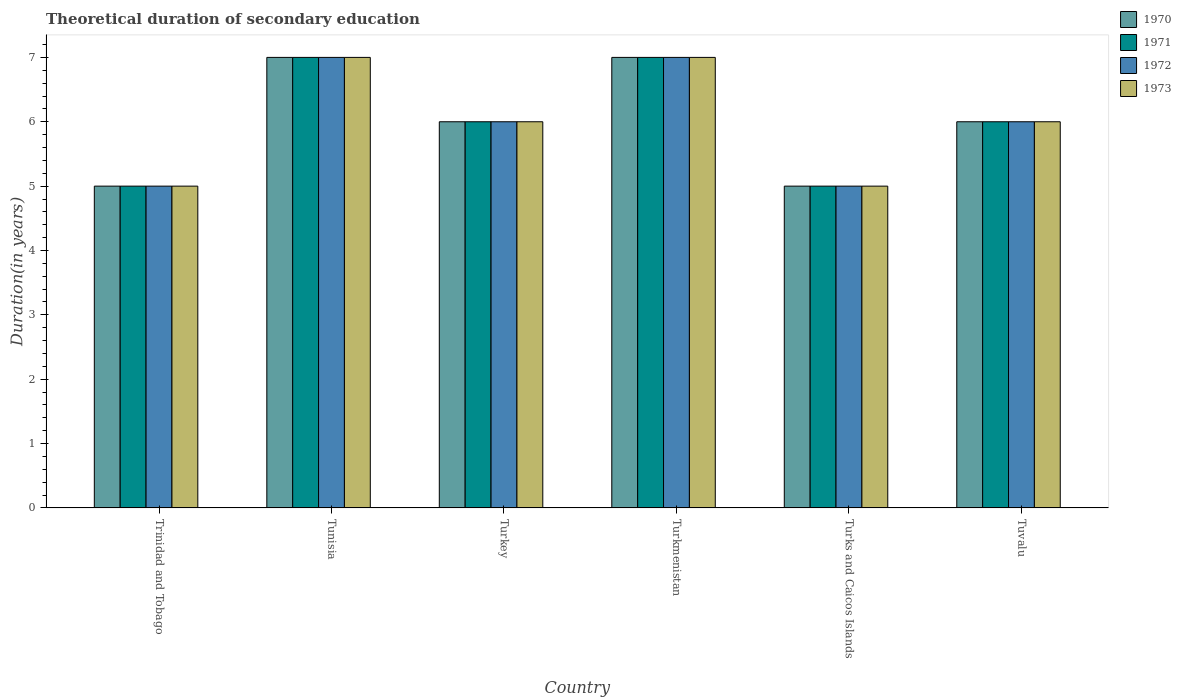Are the number of bars per tick equal to the number of legend labels?
Your response must be concise. Yes. Are the number of bars on each tick of the X-axis equal?
Your answer should be very brief. Yes. How many bars are there on the 5th tick from the right?
Offer a terse response. 4. What is the label of the 6th group of bars from the left?
Give a very brief answer. Tuvalu. In how many cases, is the number of bars for a given country not equal to the number of legend labels?
Your answer should be very brief. 0. Across all countries, what is the maximum total theoretical duration of secondary education in 1970?
Offer a terse response. 7. Across all countries, what is the minimum total theoretical duration of secondary education in 1973?
Your answer should be compact. 5. In which country was the total theoretical duration of secondary education in 1970 maximum?
Make the answer very short. Tunisia. In which country was the total theoretical duration of secondary education in 1970 minimum?
Give a very brief answer. Trinidad and Tobago. What is the difference between the total theoretical duration of secondary education in 1973 in Turks and Caicos Islands and that in Tuvalu?
Give a very brief answer. -1. What is the difference between the total theoretical duration of secondary education in 1970 in Turkmenistan and the total theoretical duration of secondary education in 1972 in Trinidad and Tobago?
Your answer should be very brief. 2. What is the average total theoretical duration of secondary education in 1973 per country?
Keep it short and to the point. 6. What is the difference between the total theoretical duration of secondary education of/in 1971 and total theoretical duration of secondary education of/in 1972 in Turkmenistan?
Your response must be concise. 0. In how many countries, is the total theoretical duration of secondary education in 1972 greater than 4 years?
Make the answer very short. 6. What is the ratio of the total theoretical duration of secondary education in 1972 in Tunisia to that in Turkey?
Provide a short and direct response. 1.17. What is the difference between the highest and the lowest total theoretical duration of secondary education in 1973?
Give a very brief answer. 2. Is the sum of the total theoretical duration of secondary education in 1973 in Trinidad and Tobago and Turkey greater than the maximum total theoretical duration of secondary education in 1971 across all countries?
Keep it short and to the point. Yes. Is it the case that in every country, the sum of the total theoretical duration of secondary education in 1972 and total theoretical duration of secondary education in 1970 is greater than the sum of total theoretical duration of secondary education in 1971 and total theoretical duration of secondary education in 1973?
Provide a succinct answer. No. What does the 1st bar from the left in Turks and Caicos Islands represents?
Offer a terse response. 1970. Are all the bars in the graph horizontal?
Provide a succinct answer. No. How many countries are there in the graph?
Provide a short and direct response. 6. Where does the legend appear in the graph?
Offer a very short reply. Top right. How many legend labels are there?
Your answer should be compact. 4. What is the title of the graph?
Provide a short and direct response. Theoretical duration of secondary education. Does "1997" appear as one of the legend labels in the graph?
Offer a terse response. No. What is the label or title of the X-axis?
Your answer should be compact. Country. What is the label or title of the Y-axis?
Provide a short and direct response. Duration(in years). What is the Duration(in years) of 1970 in Trinidad and Tobago?
Provide a succinct answer. 5. What is the Duration(in years) of 1972 in Tunisia?
Ensure brevity in your answer.  7. What is the Duration(in years) of 1973 in Tunisia?
Your response must be concise. 7. What is the Duration(in years) of 1972 in Turkey?
Provide a short and direct response. 6. What is the Duration(in years) in 1970 in Turkmenistan?
Give a very brief answer. 7. What is the Duration(in years) of 1972 in Turkmenistan?
Provide a succinct answer. 7. What is the Duration(in years) in 1970 in Turks and Caicos Islands?
Make the answer very short. 5. What is the Duration(in years) of 1971 in Turks and Caicos Islands?
Offer a terse response. 5. What is the Duration(in years) in 1970 in Tuvalu?
Your answer should be compact. 6. What is the Duration(in years) in 1971 in Tuvalu?
Your response must be concise. 6. What is the Duration(in years) in 1973 in Tuvalu?
Your answer should be very brief. 6. Across all countries, what is the maximum Duration(in years) in 1972?
Your response must be concise. 7. Across all countries, what is the maximum Duration(in years) in 1973?
Ensure brevity in your answer.  7. Across all countries, what is the minimum Duration(in years) in 1970?
Your response must be concise. 5. Across all countries, what is the minimum Duration(in years) of 1971?
Your answer should be compact. 5. Across all countries, what is the minimum Duration(in years) of 1972?
Your answer should be very brief. 5. What is the total Duration(in years) in 1972 in the graph?
Offer a terse response. 36. What is the difference between the Duration(in years) of 1972 in Trinidad and Tobago and that in Turkmenistan?
Your response must be concise. -2. What is the difference between the Duration(in years) in 1973 in Trinidad and Tobago and that in Turkmenistan?
Your response must be concise. -2. What is the difference between the Duration(in years) in 1972 in Trinidad and Tobago and that in Turks and Caicos Islands?
Keep it short and to the point. 0. What is the difference between the Duration(in years) of 1970 in Tunisia and that in Turkey?
Offer a terse response. 1. What is the difference between the Duration(in years) of 1973 in Tunisia and that in Turkey?
Keep it short and to the point. 1. What is the difference between the Duration(in years) in 1971 in Tunisia and that in Turkmenistan?
Provide a short and direct response. 0. What is the difference between the Duration(in years) of 1972 in Tunisia and that in Turkmenistan?
Offer a very short reply. 0. What is the difference between the Duration(in years) of 1970 in Tunisia and that in Turks and Caicos Islands?
Offer a very short reply. 2. What is the difference between the Duration(in years) in 1971 in Tunisia and that in Tuvalu?
Offer a terse response. 1. What is the difference between the Duration(in years) of 1973 in Tunisia and that in Tuvalu?
Your answer should be very brief. 1. What is the difference between the Duration(in years) in 1970 in Turkey and that in Turkmenistan?
Offer a terse response. -1. What is the difference between the Duration(in years) of 1971 in Turkey and that in Turkmenistan?
Provide a succinct answer. -1. What is the difference between the Duration(in years) of 1970 in Turkey and that in Turks and Caicos Islands?
Give a very brief answer. 1. What is the difference between the Duration(in years) in 1971 in Turkey and that in Turks and Caicos Islands?
Give a very brief answer. 1. What is the difference between the Duration(in years) in 1972 in Turkey and that in Turks and Caicos Islands?
Offer a very short reply. 1. What is the difference between the Duration(in years) of 1971 in Turkey and that in Tuvalu?
Offer a terse response. 0. What is the difference between the Duration(in years) in 1973 in Turkey and that in Tuvalu?
Your answer should be compact. 0. What is the difference between the Duration(in years) in 1971 in Turkmenistan and that in Turks and Caicos Islands?
Give a very brief answer. 2. What is the difference between the Duration(in years) in 1972 in Turkmenistan and that in Turks and Caicos Islands?
Your answer should be compact. 2. What is the difference between the Duration(in years) in 1970 in Turkmenistan and that in Tuvalu?
Offer a very short reply. 1. What is the difference between the Duration(in years) in 1971 in Turkmenistan and that in Tuvalu?
Your answer should be very brief. 1. What is the difference between the Duration(in years) in 1972 in Turkmenistan and that in Tuvalu?
Your response must be concise. 1. What is the difference between the Duration(in years) in 1973 in Turkmenistan and that in Tuvalu?
Offer a terse response. 1. What is the difference between the Duration(in years) of 1971 in Turks and Caicos Islands and that in Tuvalu?
Ensure brevity in your answer.  -1. What is the difference between the Duration(in years) in 1973 in Turks and Caicos Islands and that in Tuvalu?
Your answer should be compact. -1. What is the difference between the Duration(in years) of 1971 in Trinidad and Tobago and the Duration(in years) of 1972 in Tunisia?
Offer a terse response. -2. What is the difference between the Duration(in years) of 1970 in Trinidad and Tobago and the Duration(in years) of 1972 in Turkey?
Offer a terse response. -1. What is the difference between the Duration(in years) of 1971 in Trinidad and Tobago and the Duration(in years) of 1972 in Turkey?
Your answer should be compact. -1. What is the difference between the Duration(in years) of 1972 in Trinidad and Tobago and the Duration(in years) of 1973 in Turkey?
Offer a terse response. -1. What is the difference between the Duration(in years) of 1970 in Trinidad and Tobago and the Duration(in years) of 1973 in Turkmenistan?
Offer a terse response. -2. What is the difference between the Duration(in years) in 1971 in Trinidad and Tobago and the Duration(in years) in 1973 in Turkmenistan?
Your answer should be very brief. -2. What is the difference between the Duration(in years) of 1970 in Trinidad and Tobago and the Duration(in years) of 1971 in Turks and Caicos Islands?
Ensure brevity in your answer.  0. What is the difference between the Duration(in years) of 1970 in Trinidad and Tobago and the Duration(in years) of 1973 in Turks and Caicos Islands?
Offer a terse response. 0. What is the difference between the Duration(in years) of 1971 in Trinidad and Tobago and the Duration(in years) of 1972 in Turks and Caicos Islands?
Make the answer very short. 0. What is the difference between the Duration(in years) of 1972 in Trinidad and Tobago and the Duration(in years) of 1973 in Turks and Caicos Islands?
Provide a succinct answer. 0. What is the difference between the Duration(in years) of 1970 in Trinidad and Tobago and the Duration(in years) of 1972 in Tuvalu?
Provide a succinct answer. -1. What is the difference between the Duration(in years) of 1971 in Trinidad and Tobago and the Duration(in years) of 1972 in Tuvalu?
Give a very brief answer. -1. What is the difference between the Duration(in years) of 1972 in Trinidad and Tobago and the Duration(in years) of 1973 in Tuvalu?
Offer a very short reply. -1. What is the difference between the Duration(in years) of 1971 in Tunisia and the Duration(in years) of 1973 in Turkey?
Keep it short and to the point. 1. What is the difference between the Duration(in years) of 1972 in Tunisia and the Duration(in years) of 1973 in Turkey?
Offer a very short reply. 1. What is the difference between the Duration(in years) of 1970 in Tunisia and the Duration(in years) of 1973 in Turkmenistan?
Offer a very short reply. 0. What is the difference between the Duration(in years) in 1971 in Tunisia and the Duration(in years) in 1972 in Turkmenistan?
Provide a short and direct response. 0. What is the difference between the Duration(in years) in 1970 in Tunisia and the Duration(in years) in 1971 in Turks and Caicos Islands?
Your answer should be compact. 2. What is the difference between the Duration(in years) in 1970 in Tunisia and the Duration(in years) in 1972 in Turks and Caicos Islands?
Keep it short and to the point. 2. What is the difference between the Duration(in years) in 1970 in Tunisia and the Duration(in years) in 1973 in Turks and Caicos Islands?
Keep it short and to the point. 2. What is the difference between the Duration(in years) of 1972 in Tunisia and the Duration(in years) of 1973 in Turks and Caicos Islands?
Provide a succinct answer. 2. What is the difference between the Duration(in years) of 1970 in Tunisia and the Duration(in years) of 1971 in Tuvalu?
Make the answer very short. 1. What is the difference between the Duration(in years) of 1971 in Tunisia and the Duration(in years) of 1972 in Tuvalu?
Ensure brevity in your answer.  1. What is the difference between the Duration(in years) in 1972 in Tunisia and the Duration(in years) in 1973 in Tuvalu?
Your answer should be very brief. 1. What is the difference between the Duration(in years) of 1970 in Turkey and the Duration(in years) of 1972 in Turkmenistan?
Provide a short and direct response. -1. What is the difference between the Duration(in years) of 1970 in Turkey and the Duration(in years) of 1973 in Turkmenistan?
Ensure brevity in your answer.  -1. What is the difference between the Duration(in years) in 1972 in Turkey and the Duration(in years) in 1973 in Turkmenistan?
Make the answer very short. -1. What is the difference between the Duration(in years) of 1970 in Turkey and the Duration(in years) of 1971 in Turks and Caicos Islands?
Provide a succinct answer. 1. What is the difference between the Duration(in years) of 1970 in Turkey and the Duration(in years) of 1972 in Turks and Caicos Islands?
Provide a succinct answer. 1. What is the difference between the Duration(in years) in 1970 in Turkey and the Duration(in years) in 1973 in Turks and Caicos Islands?
Ensure brevity in your answer.  1. What is the difference between the Duration(in years) of 1972 in Turkey and the Duration(in years) of 1973 in Turks and Caicos Islands?
Provide a short and direct response. 1. What is the difference between the Duration(in years) of 1970 in Turkey and the Duration(in years) of 1973 in Tuvalu?
Your answer should be very brief. 0. What is the difference between the Duration(in years) of 1971 in Turkey and the Duration(in years) of 1973 in Tuvalu?
Give a very brief answer. 0. What is the difference between the Duration(in years) of 1972 in Turkey and the Duration(in years) of 1973 in Tuvalu?
Ensure brevity in your answer.  0. What is the difference between the Duration(in years) of 1971 in Turkmenistan and the Duration(in years) of 1972 in Turks and Caicos Islands?
Offer a terse response. 2. What is the difference between the Duration(in years) in 1971 in Turkmenistan and the Duration(in years) in 1973 in Turks and Caicos Islands?
Keep it short and to the point. 2. What is the difference between the Duration(in years) in 1970 in Turkmenistan and the Duration(in years) in 1971 in Tuvalu?
Your answer should be compact. 1. What is the difference between the Duration(in years) of 1971 in Turkmenistan and the Duration(in years) of 1972 in Tuvalu?
Offer a terse response. 1. What is the difference between the Duration(in years) of 1970 in Turks and Caicos Islands and the Duration(in years) of 1972 in Tuvalu?
Ensure brevity in your answer.  -1. What is the difference between the Duration(in years) in 1971 in Turks and Caicos Islands and the Duration(in years) in 1973 in Tuvalu?
Make the answer very short. -1. What is the difference between the Duration(in years) in 1972 in Turks and Caicos Islands and the Duration(in years) in 1973 in Tuvalu?
Your answer should be compact. -1. What is the average Duration(in years) of 1973 per country?
Offer a terse response. 6. What is the difference between the Duration(in years) of 1970 and Duration(in years) of 1971 in Trinidad and Tobago?
Make the answer very short. 0. What is the difference between the Duration(in years) of 1970 and Duration(in years) of 1972 in Trinidad and Tobago?
Give a very brief answer. 0. What is the difference between the Duration(in years) in 1970 and Duration(in years) in 1973 in Trinidad and Tobago?
Provide a succinct answer. 0. What is the difference between the Duration(in years) of 1972 and Duration(in years) of 1973 in Trinidad and Tobago?
Your response must be concise. 0. What is the difference between the Duration(in years) of 1970 and Duration(in years) of 1973 in Tunisia?
Offer a terse response. 0. What is the difference between the Duration(in years) of 1972 and Duration(in years) of 1973 in Tunisia?
Your answer should be compact. 0. What is the difference between the Duration(in years) in 1970 and Duration(in years) in 1971 in Turkey?
Your answer should be compact. 0. What is the difference between the Duration(in years) in 1970 and Duration(in years) in 1973 in Turkey?
Keep it short and to the point. 0. What is the difference between the Duration(in years) in 1971 and Duration(in years) in 1972 in Turkey?
Your response must be concise. 0. What is the difference between the Duration(in years) in 1970 and Duration(in years) in 1971 in Turkmenistan?
Give a very brief answer. 0. What is the difference between the Duration(in years) of 1970 and Duration(in years) of 1972 in Turkmenistan?
Your answer should be compact. 0. What is the difference between the Duration(in years) in 1971 and Duration(in years) in 1972 in Turkmenistan?
Keep it short and to the point. 0. What is the difference between the Duration(in years) in 1971 and Duration(in years) in 1973 in Turkmenistan?
Offer a terse response. 0. What is the difference between the Duration(in years) of 1972 and Duration(in years) of 1973 in Turkmenistan?
Make the answer very short. 0. What is the difference between the Duration(in years) of 1970 and Duration(in years) of 1973 in Turks and Caicos Islands?
Your answer should be very brief. 0. What is the difference between the Duration(in years) in 1971 and Duration(in years) in 1972 in Turks and Caicos Islands?
Ensure brevity in your answer.  0. What is the difference between the Duration(in years) in 1971 and Duration(in years) in 1973 in Turks and Caicos Islands?
Provide a short and direct response. 0. What is the difference between the Duration(in years) of 1972 and Duration(in years) of 1973 in Turks and Caicos Islands?
Provide a short and direct response. 0. What is the difference between the Duration(in years) in 1970 and Duration(in years) in 1973 in Tuvalu?
Make the answer very short. 0. What is the ratio of the Duration(in years) in 1970 in Trinidad and Tobago to that in Tunisia?
Give a very brief answer. 0.71. What is the ratio of the Duration(in years) of 1972 in Trinidad and Tobago to that in Tunisia?
Ensure brevity in your answer.  0.71. What is the ratio of the Duration(in years) in 1972 in Trinidad and Tobago to that in Turkey?
Offer a very short reply. 0.83. What is the ratio of the Duration(in years) of 1973 in Trinidad and Tobago to that in Turkey?
Provide a short and direct response. 0.83. What is the ratio of the Duration(in years) of 1972 in Trinidad and Tobago to that in Turkmenistan?
Make the answer very short. 0.71. What is the ratio of the Duration(in years) in 1973 in Trinidad and Tobago to that in Turkmenistan?
Your answer should be very brief. 0.71. What is the ratio of the Duration(in years) in 1970 in Trinidad and Tobago to that in Turks and Caicos Islands?
Give a very brief answer. 1. What is the ratio of the Duration(in years) in 1971 in Trinidad and Tobago to that in Turks and Caicos Islands?
Offer a very short reply. 1. What is the ratio of the Duration(in years) of 1973 in Trinidad and Tobago to that in Turks and Caicos Islands?
Keep it short and to the point. 1. What is the ratio of the Duration(in years) of 1972 in Trinidad and Tobago to that in Tuvalu?
Keep it short and to the point. 0.83. What is the ratio of the Duration(in years) in 1973 in Trinidad and Tobago to that in Tuvalu?
Provide a short and direct response. 0.83. What is the ratio of the Duration(in years) in 1970 in Tunisia to that in Turkey?
Your answer should be very brief. 1.17. What is the ratio of the Duration(in years) in 1971 in Tunisia to that in Turkey?
Offer a very short reply. 1.17. What is the ratio of the Duration(in years) of 1973 in Tunisia to that in Turkey?
Your answer should be compact. 1.17. What is the ratio of the Duration(in years) of 1971 in Tunisia to that in Turkmenistan?
Offer a very short reply. 1. What is the ratio of the Duration(in years) of 1972 in Tunisia to that in Turkmenistan?
Ensure brevity in your answer.  1. What is the ratio of the Duration(in years) in 1972 in Tunisia to that in Turks and Caicos Islands?
Your answer should be very brief. 1.4. What is the ratio of the Duration(in years) of 1971 in Tunisia to that in Tuvalu?
Ensure brevity in your answer.  1.17. What is the ratio of the Duration(in years) in 1972 in Tunisia to that in Tuvalu?
Your answer should be compact. 1.17. What is the ratio of the Duration(in years) of 1971 in Turkey to that in Turkmenistan?
Your answer should be compact. 0.86. What is the ratio of the Duration(in years) of 1972 in Turkey to that in Turkmenistan?
Give a very brief answer. 0.86. What is the ratio of the Duration(in years) in 1970 in Turkey to that in Turks and Caicos Islands?
Keep it short and to the point. 1.2. What is the ratio of the Duration(in years) of 1973 in Turkey to that in Turks and Caicos Islands?
Ensure brevity in your answer.  1.2. What is the ratio of the Duration(in years) in 1970 in Turkmenistan to that in Turks and Caicos Islands?
Offer a very short reply. 1.4. What is the ratio of the Duration(in years) in 1972 in Turkmenistan to that in Turks and Caicos Islands?
Your answer should be compact. 1.4. What is the ratio of the Duration(in years) in 1973 in Turkmenistan to that in Turks and Caicos Islands?
Your answer should be very brief. 1.4. What is the ratio of the Duration(in years) in 1970 in Turkmenistan to that in Tuvalu?
Offer a terse response. 1.17. What is the ratio of the Duration(in years) in 1971 in Turkmenistan to that in Tuvalu?
Ensure brevity in your answer.  1.17. What is the ratio of the Duration(in years) of 1973 in Turkmenistan to that in Tuvalu?
Give a very brief answer. 1.17. What is the ratio of the Duration(in years) of 1970 in Turks and Caicos Islands to that in Tuvalu?
Offer a terse response. 0.83. What is the ratio of the Duration(in years) in 1973 in Turks and Caicos Islands to that in Tuvalu?
Keep it short and to the point. 0.83. What is the difference between the highest and the second highest Duration(in years) of 1971?
Provide a succinct answer. 0. What is the difference between the highest and the second highest Duration(in years) of 1973?
Ensure brevity in your answer.  0. What is the difference between the highest and the lowest Duration(in years) in 1972?
Ensure brevity in your answer.  2. What is the difference between the highest and the lowest Duration(in years) in 1973?
Offer a very short reply. 2. 